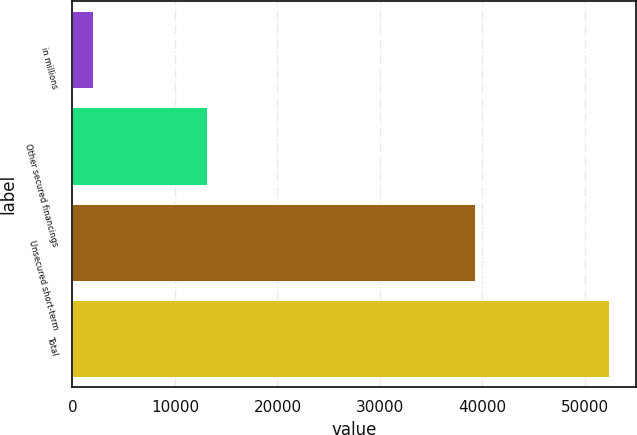<chart> <loc_0><loc_0><loc_500><loc_500><bar_chart><fcel>in millions<fcel>Other secured financings<fcel>Unsecured short-term<fcel>Total<nl><fcel>2016<fcel>13118<fcel>39265<fcel>52383<nl></chart> 